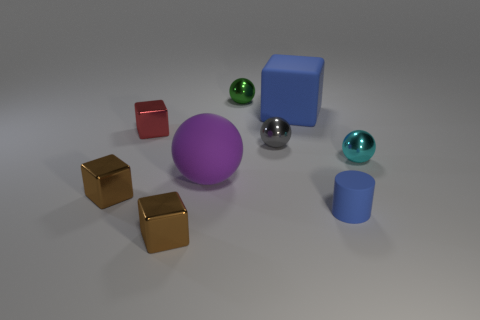What can you infer about the material characteristics of the objects? Based on their appearances, the objects seem to be made of different materials. The yellow cubes and the red cube have a matte finish, which suggests they could be made of colored plastic or coated metal. The large purple sphere, small silver sphere, and teal sphere have reflective surfaces, indicating they are likely made of metal. Lastly, the blue cube and cylinder exhibit a subtle sheen and smoothness, which could mean they are either made of painted wood or plastic. 